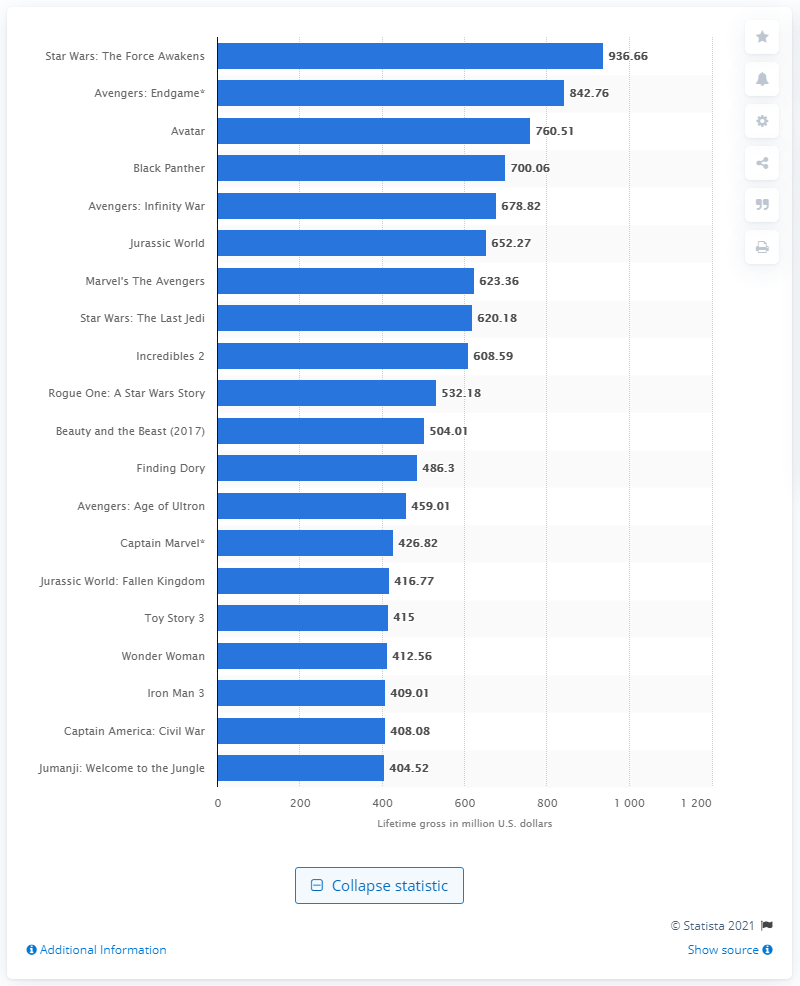Give some essential details in this illustration. The movie that had the highest lifetime gross at the North American box office is Star Wars: The Force Awakens. The box office revenue of Avengers: Endgame in the United States was reported to be 842.76 million dollars. The box office revenue of 'Avatar' was $760.51. 